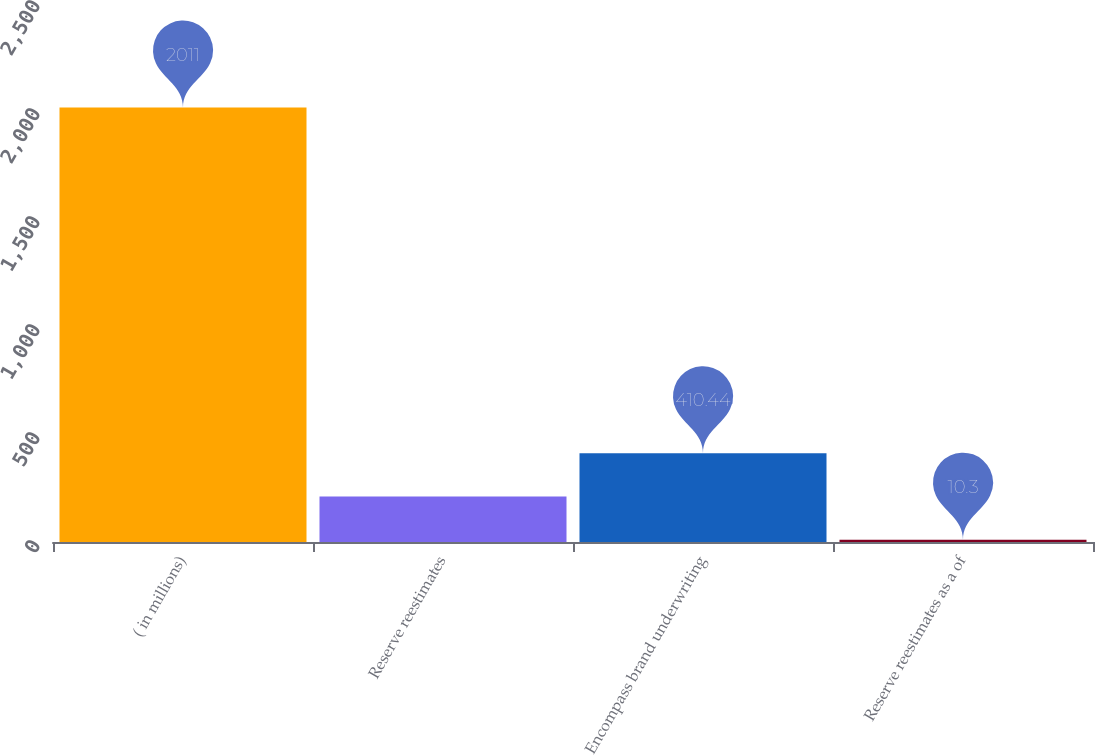Convert chart to OTSL. <chart><loc_0><loc_0><loc_500><loc_500><bar_chart><fcel>( in millions)<fcel>Reserve reestimates<fcel>Encompass brand underwriting<fcel>Reserve reestimates as a of<nl><fcel>2011<fcel>210.37<fcel>410.44<fcel>10.3<nl></chart> 